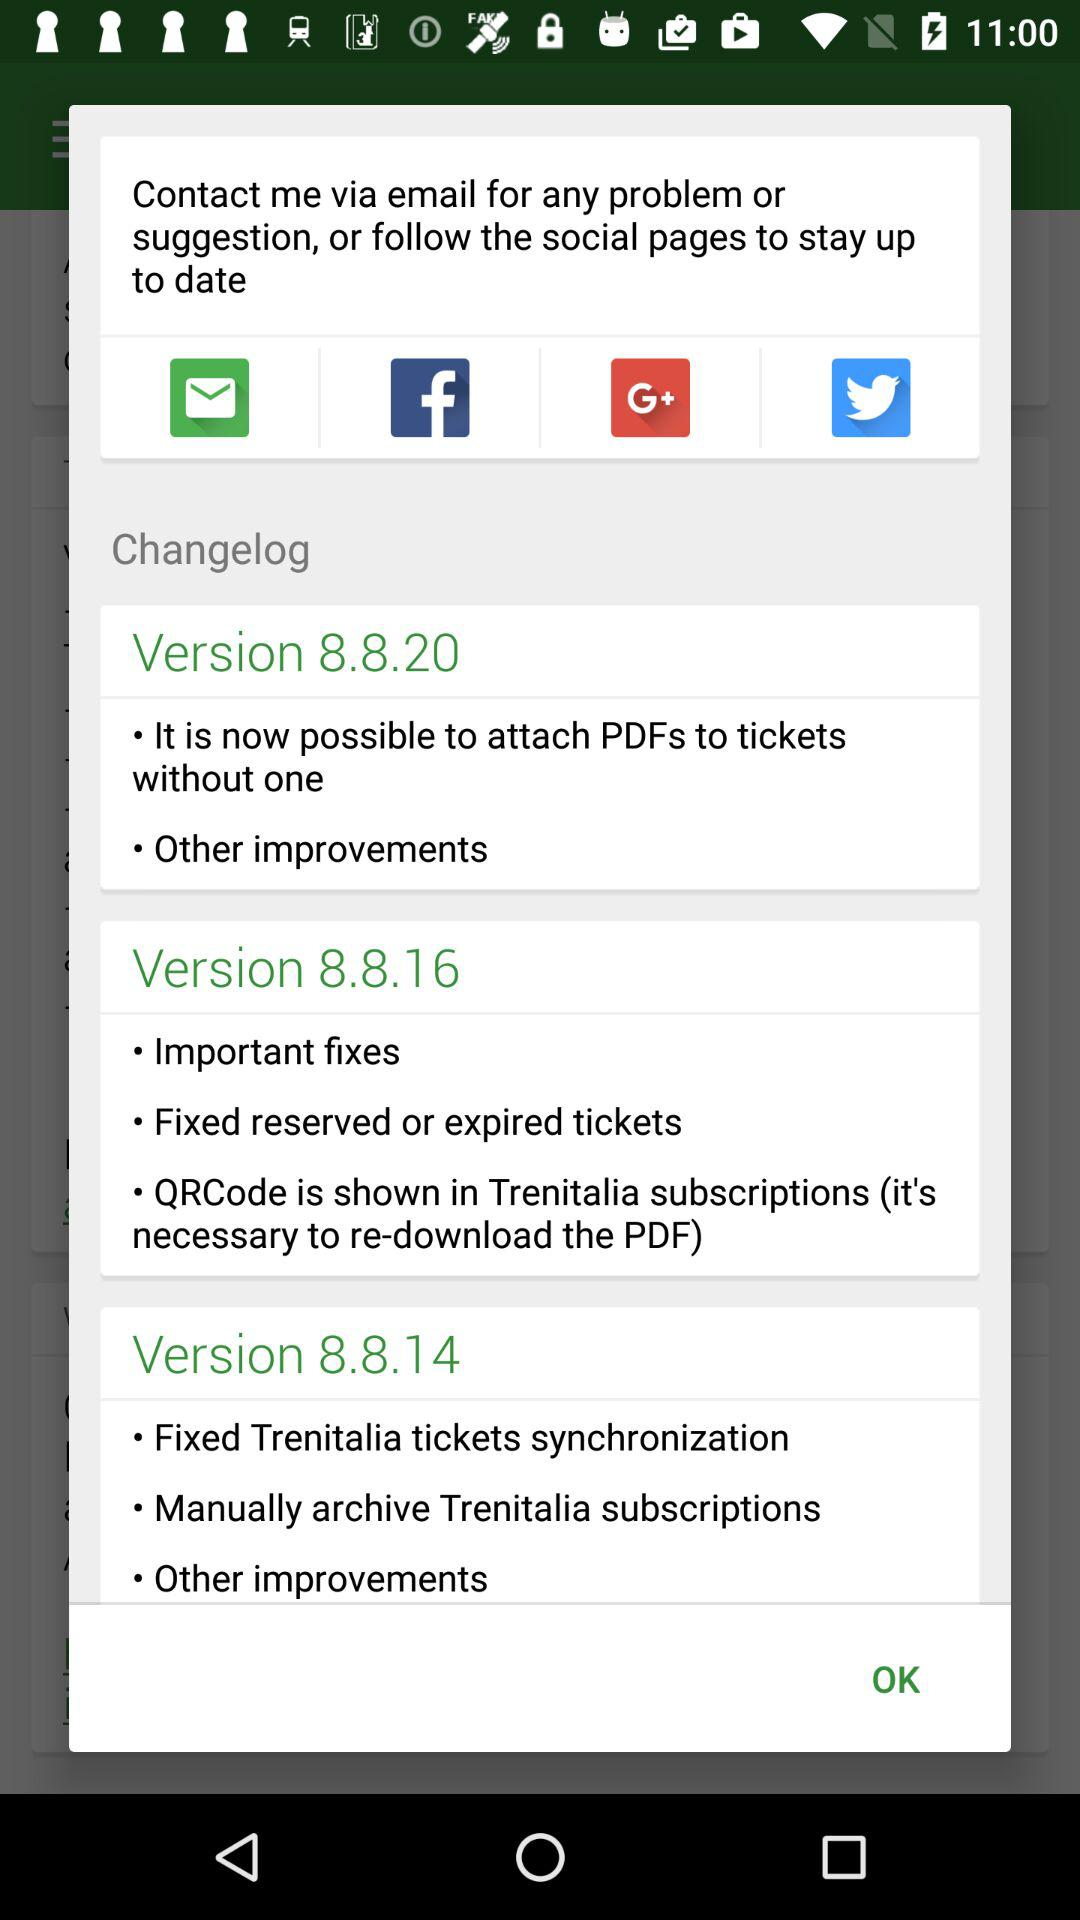Which applications can be used to follow the social pages to stay up-to-date? The applications that can be used to follow the social pages to stay up-to-date are "Facebook", "Google+" and "Twitter". 